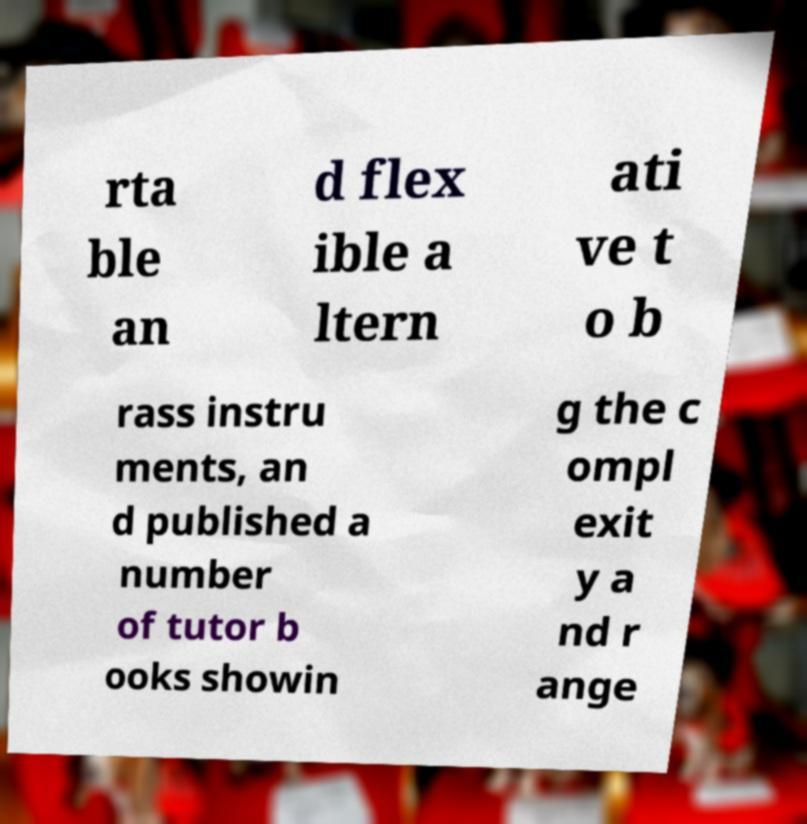What messages or text are displayed in this image? I need them in a readable, typed format. rta ble an d flex ible a ltern ati ve t o b rass instru ments, an d published a number of tutor b ooks showin g the c ompl exit y a nd r ange 